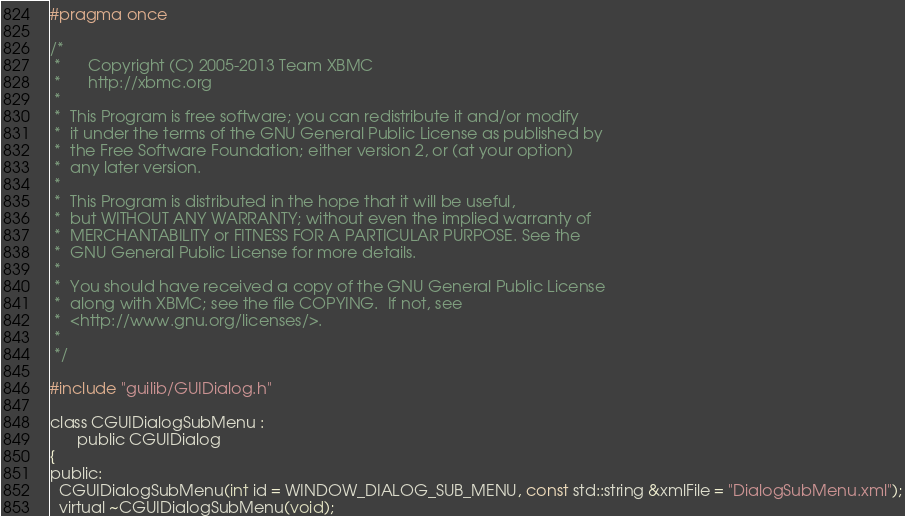Convert code to text. <code><loc_0><loc_0><loc_500><loc_500><_C_>#pragma once

/*
 *      Copyright (C) 2005-2013 Team XBMC
 *      http://xbmc.org
 *
 *  This Program is free software; you can redistribute it and/or modify
 *  it under the terms of the GNU General Public License as published by
 *  the Free Software Foundation; either version 2, or (at your option)
 *  any later version.
 *
 *  This Program is distributed in the hope that it will be useful,
 *  but WITHOUT ANY WARRANTY; without even the implied warranty of
 *  MERCHANTABILITY or FITNESS FOR A PARTICULAR PURPOSE. See the
 *  GNU General Public License for more details.
 *
 *  You should have received a copy of the GNU General Public License
 *  along with XBMC; see the file COPYING.  If not, see
 *  <http://www.gnu.org/licenses/>.
 *
 */

#include "guilib/GUIDialog.h"

class CGUIDialogSubMenu :
      public CGUIDialog
{
public:
  CGUIDialogSubMenu(int id = WINDOW_DIALOG_SUB_MENU, const std::string &xmlFile = "DialogSubMenu.xml");
  virtual ~CGUIDialogSubMenu(void);</code> 